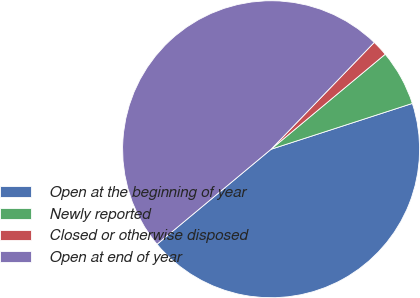Convert chart to OTSL. <chart><loc_0><loc_0><loc_500><loc_500><pie_chart><fcel>Open at the beginning of year<fcel>Newly reported<fcel>Closed or otherwise disposed<fcel>Open at end of year<nl><fcel>43.94%<fcel>6.06%<fcel>1.73%<fcel>48.27%<nl></chart> 